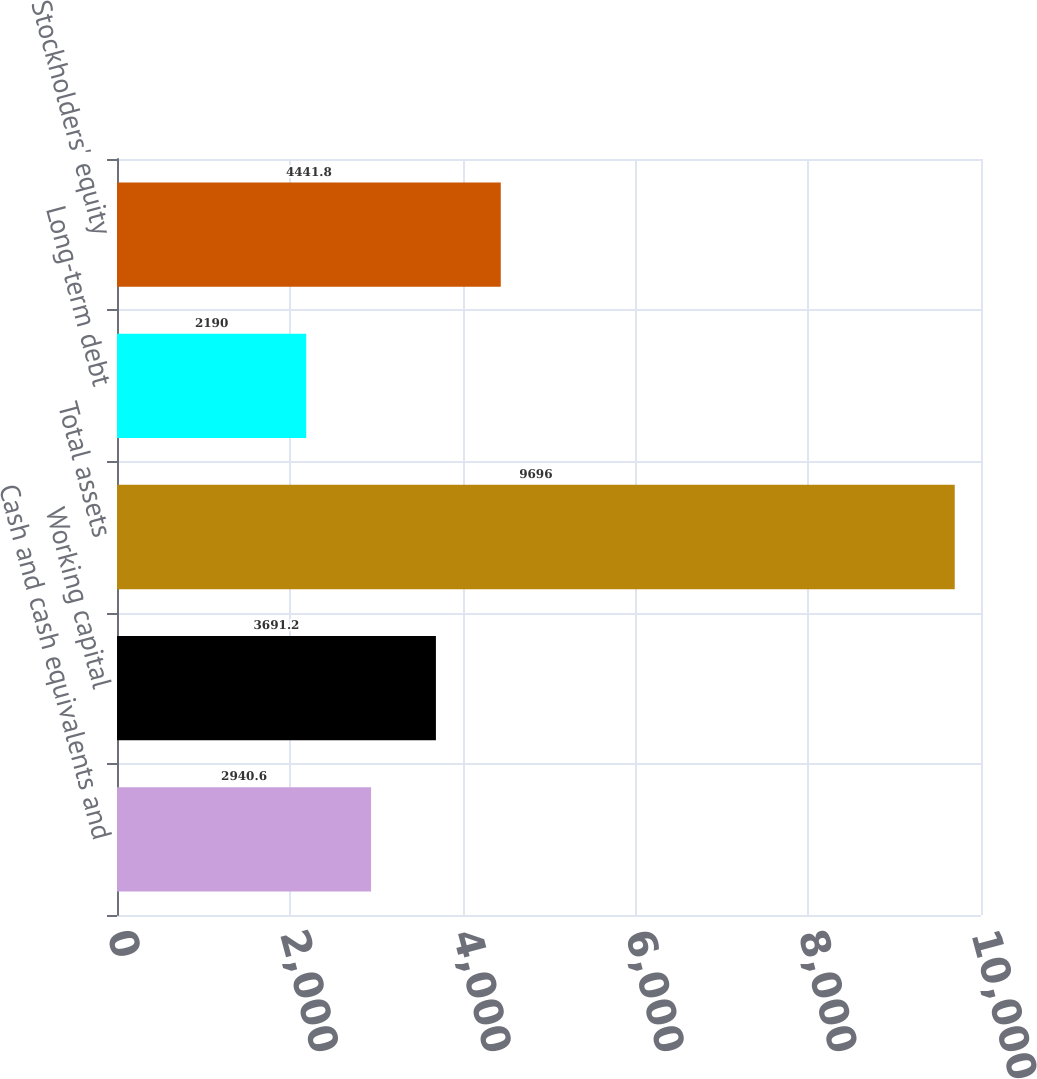Convert chart to OTSL. <chart><loc_0><loc_0><loc_500><loc_500><bar_chart><fcel>Cash and cash equivalents and<fcel>Working capital<fcel>Total assets<fcel>Long-term debt<fcel>Stockholders' equity<nl><fcel>2940.6<fcel>3691.2<fcel>9696<fcel>2190<fcel>4441.8<nl></chart> 